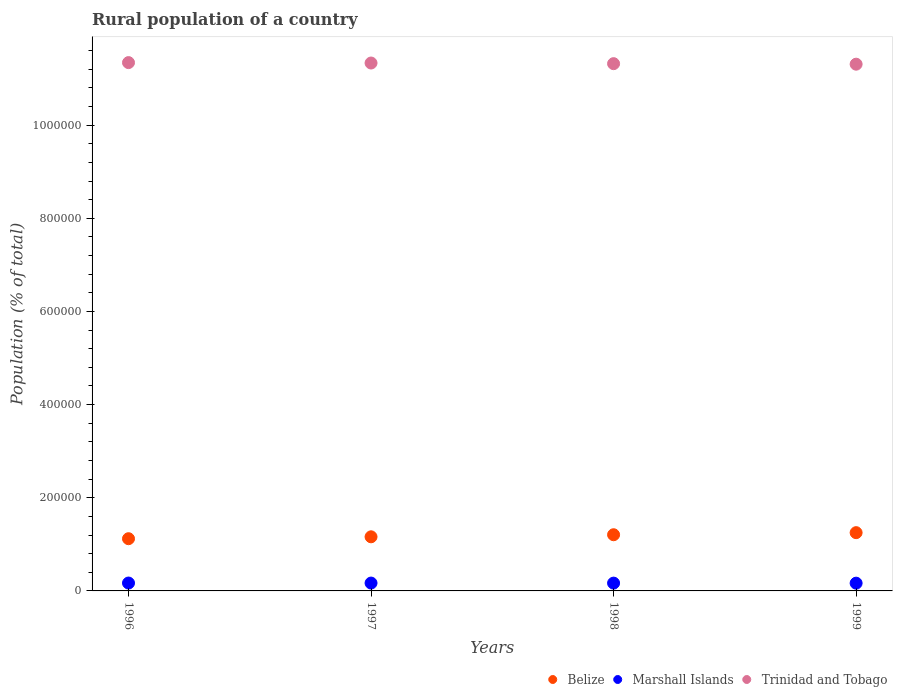How many different coloured dotlines are there?
Provide a succinct answer. 3. What is the rural population in Marshall Islands in 1998?
Your response must be concise. 1.68e+04. Across all years, what is the maximum rural population in Marshall Islands?
Provide a short and direct response. 1.69e+04. Across all years, what is the minimum rural population in Marshall Islands?
Ensure brevity in your answer.  1.66e+04. What is the total rural population in Trinidad and Tobago in the graph?
Give a very brief answer. 4.53e+06. What is the difference between the rural population in Trinidad and Tobago in 1996 and that in 1998?
Keep it short and to the point. 2281. What is the difference between the rural population in Belize in 1997 and the rural population in Trinidad and Tobago in 1996?
Your answer should be very brief. -1.02e+06. What is the average rural population in Marshall Islands per year?
Your answer should be compact. 1.68e+04. In the year 1996, what is the difference between the rural population in Trinidad and Tobago and rural population in Marshall Islands?
Ensure brevity in your answer.  1.12e+06. What is the ratio of the rural population in Belize in 1996 to that in 1999?
Give a very brief answer. 0.9. What is the difference between the highest and the lowest rural population in Marshall Islands?
Offer a terse response. 286. Is the sum of the rural population in Belize in 1998 and 1999 greater than the maximum rural population in Marshall Islands across all years?
Ensure brevity in your answer.  Yes. Does the rural population in Trinidad and Tobago monotonically increase over the years?
Offer a very short reply. No. How many dotlines are there?
Provide a short and direct response. 3. Where does the legend appear in the graph?
Make the answer very short. Bottom right. How many legend labels are there?
Provide a short and direct response. 3. What is the title of the graph?
Ensure brevity in your answer.  Rural population of a country. Does "Guatemala" appear as one of the legend labels in the graph?
Ensure brevity in your answer.  No. What is the label or title of the Y-axis?
Offer a terse response. Population (% of total). What is the Population (% of total) of Belize in 1996?
Keep it short and to the point. 1.12e+05. What is the Population (% of total) in Marshall Islands in 1996?
Provide a succinct answer. 1.69e+04. What is the Population (% of total) in Trinidad and Tobago in 1996?
Offer a very short reply. 1.13e+06. What is the Population (% of total) in Belize in 1997?
Provide a short and direct response. 1.16e+05. What is the Population (% of total) of Marshall Islands in 1997?
Your response must be concise. 1.69e+04. What is the Population (% of total) in Trinidad and Tobago in 1997?
Give a very brief answer. 1.13e+06. What is the Population (% of total) of Belize in 1998?
Give a very brief answer. 1.21e+05. What is the Population (% of total) of Marshall Islands in 1998?
Offer a terse response. 1.68e+04. What is the Population (% of total) in Trinidad and Tobago in 1998?
Make the answer very short. 1.13e+06. What is the Population (% of total) of Belize in 1999?
Offer a terse response. 1.25e+05. What is the Population (% of total) in Marshall Islands in 1999?
Your answer should be very brief. 1.66e+04. What is the Population (% of total) of Trinidad and Tobago in 1999?
Offer a terse response. 1.13e+06. Across all years, what is the maximum Population (% of total) in Belize?
Provide a succinct answer. 1.25e+05. Across all years, what is the maximum Population (% of total) in Marshall Islands?
Your answer should be compact. 1.69e+04. Across all years, what is the maximum Population (% of total) of Trinidad and Tobago?
Your answer should be very brief. 1.13e+06. Across all years, what is the minimum Population (% of total) in Belize?
Keep it short and to the point. 1.12e+05. Across all years, what is the minimum Population (% of total) of Marshall Islands?
Provide a succinct answer. 1.66e+04. Across all years, what is the minimum Population (% of total) in Trinidad and Tobago?
Your response must be concise. 1.13e+06. What is the total Population (% of total) of Belize in the graph?
Provide a succinct answer. 4.74e+05. What is the total Population (% of total) of Marshall Islands in the graph?
Ensure brevity in your answer.  6.72e+04. What is the total Population (% of total) in Trinidad and Tobago in the graph?
Provide a short and direct response. 4.53e+06. What is the difference between the Population (% of total) in Belize in 1996 and that in 1997?
Provide a succinct answer. -4063. What is the difference between the Population (% of total) in Trinidad and Tobago in 1996 and that in 1997?
Your answer should be very brief. 904. What is the difference between the Population (% of total) of Belize in 1996 and that in 1998?
Keep it short and to the point. -8513. What is the difference between the Population (% of total) in Marshall Islands in 1996 and that in 1998?
Make the answer very short. 166. What is the difference between the Population (% of total) of Trinidad and Tobago in 1996 and that in 1998?
Provide a short and direct response. 2281. What is the difference between the Population (% of total) of Belize in 1996 and that in 1999?
Make the answer very short. -1.30e+04. What is the difference between the Population (% of total) of Marshall Islands in 1996 and that in 1999?
Your answer should be very brief. 286. What is the difference between the Population (% of total) in Trinidad and Tobago in 1996 and that in 1999?
Keep it short and to the point. 3399. What is the difference between the Population (% of total) of Belize in 1997 and that in 1998?
Your answer should be compact. -4450. What is the difference between the Population (% of total) in Marshall Islands in 1997 and that in 1998?
Provide a short and direct response. 96. What is the difference between the Population (% of total) in Trinidad and Tobago in 1997 and that in 1998?
Offer a very short reply. 1377. What is the difference between the Population (% of total) of Belize in 1997 and that in 1999?
Provide a short and direct response. -8918. What is the difference between the Population (% of total) in Marshall Islands in 1997 and that in 1999?
Give a very brief answer. 216. What is the difference between the Population (% of total) of Trinidad and Tobago in 1997 and that in 1999?
Provide a succinct answer. 2495. What is the difference between the Population (% of total) in Belize in 1998 and that in 1999?
Offer a very short reply. -4468. What is the difference between the Population (% of total) of Marshall Islands in 1998 and that in 1999?
Provide a short and direct response. 120. What is the difference between the Population (% of total) in Trinidad and Tobago in 1998 and that in 1999?
Make the answer very short. 1118. What is the difference between the Population (% of total) of Belize in 1996 and the Population (% of total) of Marshall Islands in 1997?
Your answer should be compact. 9.53e+04. What is the difference between the Population (% of total) in Belize in 1996 and the Population (% of total) in Trinidad and Tobago in 1997?
Offer a terse response. -1.02e+06. What is the difference between the Population (% of total) in Marshall Islands in 1996 and the Population (% of total) in Trinidad and Tobago in 1997?
Provide a short and direct response. -1.12e+06. What is the difference between the Population (% of total) in Belize in 1996 and the Population (% of total) in Marshall Islands in 1998?
Ensure brevity in your answer.  9.54e+04. What is the difference between the Population (% of total) in Belize in 1996 and the Population (% of total) in Trinidad and Tobago in 1998?
Ensure brevity in your answer.  -1.02e+06. What is the difference between the Population (% of total) in Marshall Islands in 1996 and the Population (% of total) in Trinidad and Tobago in 1998?
Offer a very short reply. -1.12e+06. What is the difference between the Population (% of total) in Belize in 1996 and the Population (% of total) in Marshall Islands in 1999?
Give a very brief answer. 9.55e+04. What is the difference between the Population (% of total) of Belize in 1996 and the Population (% of total) of Trinidad and Tobago in 1999?
Provide a short and direct response. -1.02e+06. What is the difference between the Population (% of total) in Marshall Islands in 1996 and the Population (% of total) in Trinidad and Tobago in 1999?
Your answer should be compact. -1.11e+06. What is the difference between the Population (% of total) in Belize in 1997 and the Population (% of total) in Marshall Islands in 1998?
Your answer should be very brief. 9.94e+04. What is the difference between the Population (% of total) of Belize in 1997 and the Population (% of total) of Trinidad and Tobago in 1998?
Make the answer very short. -1.02e+06. What is the difference between the Population (% of total) of Marshall Islands in 1997 and the Population (% of total) of Trinidad and Tobago in 1998?
Your response must be concise. -1.12e+06. What is the difference between the Population (% of total) in Belize in 1997 and the Population (% of total) in Marshall Islands in 1999?
Ensure brevity in your answer.  9.95e+04. What is the difference between the Population (% of total) of Belize in 1997 and the Population (% of total) of Trinidad and Tobago in 1999?
Provide a short and direct response. -1.01e+06. What is the difference between the Population (% of total) of Marshall Islands in 1997 and the Population (% of total) of Trinidad and Tobago in 1999?
Make the answer very short. -1.11e+06. What is the difference between the Population (% of total) of Belize in 1998 and the Population (% of total) of Marshall Islands in 1999?
Your answer should be compact. 1.04e+05. What is the difference between the Population (% of total) of Belize in 1998 and the Population (% of total) of Trinidad and Tobago in 1999?
Your answer should be compact. -1.01e+06. What is the difference between the Population (% of total) in Marshall Islands in 1998 and the Population (% of total) in Trinidad and Tobago in 1999?
Provide a short and direct response. -1.11e+06. What is the average Population (% of total) of Belize per year?
Provide a succinct answer. 1.19e+05. What is the average Population (% of total) in Marshall Islands per year?
Keep it short and to the point. 1.68e+04. What is the average Population (% of total) of Trinidad and Tobago per year?
Your answer should be very brief. 1.13e+06. In the year 1996, what is the difference between the Population (% of total) of Belize and Population (% of total) of Marshall Islands?
Provide a succinct answer. 9.52e+04. In the year 1996, what is the difference between the Population (% of total) of Belize and Population (% of total) of Trinidad and Tobago?
Give a very brief answer. -1.02e+06. In the year 1996, what is the difference between the Population (% of total) in Marshall Islands and Population (% of total) in Trinidad and Tobago?
Offer a very short reply. -1.12e+06. In the year 1997, what is the difference between the Population (% of total) of Belize and Population (% of total) of Marshall Islands?
Your response must be concise. 9.93e+04. In the year 1997, what is the difference between the Population (% of total) of Belize and Population (% of total) of Trinidad and Tobago?
Provide a short and direct response. -1.02e+06. In the year 1997, what is the difference between the Population (% of total) of Marshall Islands and Population (% of total) of Trinidad and Tobago?
Your answer should be compact. -1.12e+06. In the year 1998, what is the difference between the Population (% of total) in Belize and Population (% of total) in Marshall Islands?
Give a very brief answer. 1.04e+05. In the year 1998, what is the difference between the Population (% of total) of Belize and Population (% of total) of Trinidad and Tobago?
Your answer should be very brief. -1.01e+06. In the year 1998, what is the difference between the Population (% of total) in Marshall Islands and Population (% of total) in Trinidad and Tobago?
Keep it short and to the point. -1.12e+06. In the year 1999, what is the difference between the Population (% of total) of Belize and Population (% of total) of Marshall Islands?
Offer a terse response. 1.08e+05. In the year 1999, what is the difference between the Population (% of total) of Belize and Population (% of total) of Trinidad and Tobago?
Give a very brief answer. -1.01e+06. In the year 1999, what is the difference between the Population (% of total) in Marshall Islands and Population (% of total) in Trinidad and Tobago?
Give a very brief answer. -1.11e+06. What is the ratio of the Population (% of total) in Marshall Islands in 1996 to that in 1997?
Provide a succinct answer. 1. What is the ratio of the Population (% of total) of Belize in 1996 to that in 1998?
Give a very brief answer. 0.93. What is the ratio of the Population (% of total) of Marshall Islands in 1996 to that in 1998?
Offer a terse response. 1.01. What is the ratio of the Population (% of total) of Trinidad and Tobago in 1996 to that in 1998?
Your answer should be compact. 1. What is the ratio of the Population (% of total) in Belize in 1996 to that in 1999?
Offer a terse response. 0.9. What is the ratio of the Population (% of total) of Marshall Islands in 1996 to that in 1999?
Your response must be concise. 1.02. What is the ratio of the Population (% of total) in Belize in 1997 to that in 1998?
Provide a short and direct response. 0.96. What is the ratio of the Population (% of total) in Marshall Islands in 1997 to that in 1998?
Provide a succinct answer. 1.01. What is the ratio of the Population (% of total) of Trinidad and Tobago in 1997 to that in 1998?
Ensure brevity in your answer.  1. What is the ratio of the Population (% of total) of Belize in 1997 to that in 1999?
Your answer should be compact. 0.93. What is the ratio of the Population (% of total) in Marshall Islands in 1997 to that in 1999?
Provide a succinct answer. 1.01. What is the ratio of the Population (% of total) of Trinidad and Tobago in 1998 to that in 1999?
Provide a short and direct response. 1. What is the difference between the highest and the second highest Population (% of total) of Belize?
Offer a very short reply. 4468. What is the difference between the highest and the second highest Population (% of total) in Marshall Islands?
Make the answer very short. 70. What is the difference between the highest and the second highest Population (% of total) of Trinidad and Tobago?
Ensure brevity in your answer.  904. What is the difference between the highest and the lowest Population (% of total) of Belize?
Your response must be concise. 1.30e+04. What is the difference between the highest and the lowest Population (% of total) of Marshall Islands?
Offer a terse response. 286. What is the difference between the highest and the lowest Population (% of total) in Trinidad and Tobago?
Give a very brief answer. 3399. 